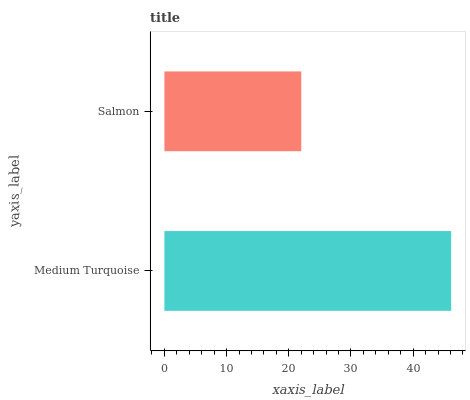Is Salmon the minimum?
Answer yes or no. Yes. Is Medium Turquoise the maximum?
Answer yes or no. Yes. Is Salmon the maximum?
Answer yes or no. No. Is Medium Turquoise greater than Salmon?
Answer yes or no. Yes. Is Salmon less than Medium Turquoise?
Answer yes or no. Yes. Is Salmon greater than Medium Turquoise?
Answer yes or no. No. Is Medium Turquoise less than Salmon?
Answer yes or no. No. Is Medium Turquoise the high median?
Answer yes or no. Yes. Is Salmon the low median?
Answer yes or no. Yes. Is Salmon the high median?
Answer yes or no. No. Is Medium Turquoise the low median?
Answer yes or no. No. 